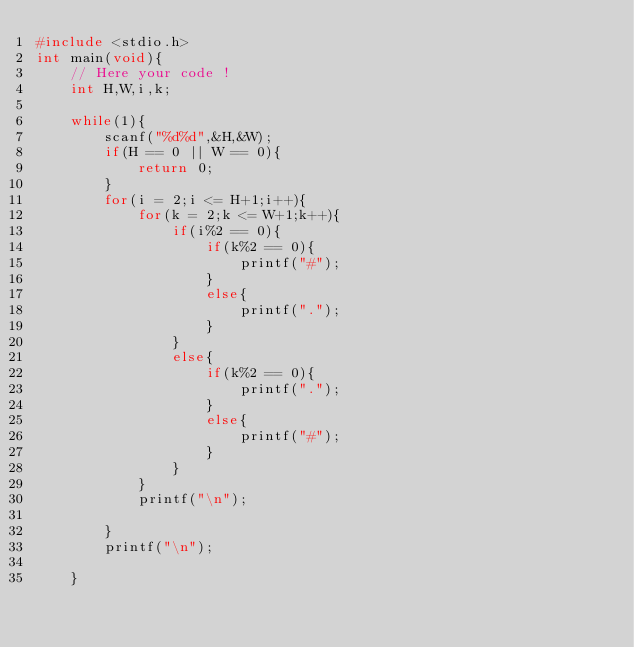Convert code to text. <code><loc_0><loc_0><loc_500><loc_500><_C_>#include <stdio.h>
int main(void){
    // Here your code !
    int H,W,i,k;
    
    while(1){
        scanf("%d%d",&H,&W);
        if(H == 0 || W == 0){
            return 0;
        }
        for(i = 2;i <= H+1;i++){
            for(k = 2;k <= W+1;k++){
                if(i%2 == 0){
                    if(k%2 == 0){
                        printf("#");
                    }
                    else{
                        printf(".");
                    }
                }
                else{
                    if(k%2 == 0){
                        printf(".");
                    }
                    else{
                        printf("#");
                    }
                }
            }
            printf("\n");
            
        }
        printf("\n");
        
    }</code> 